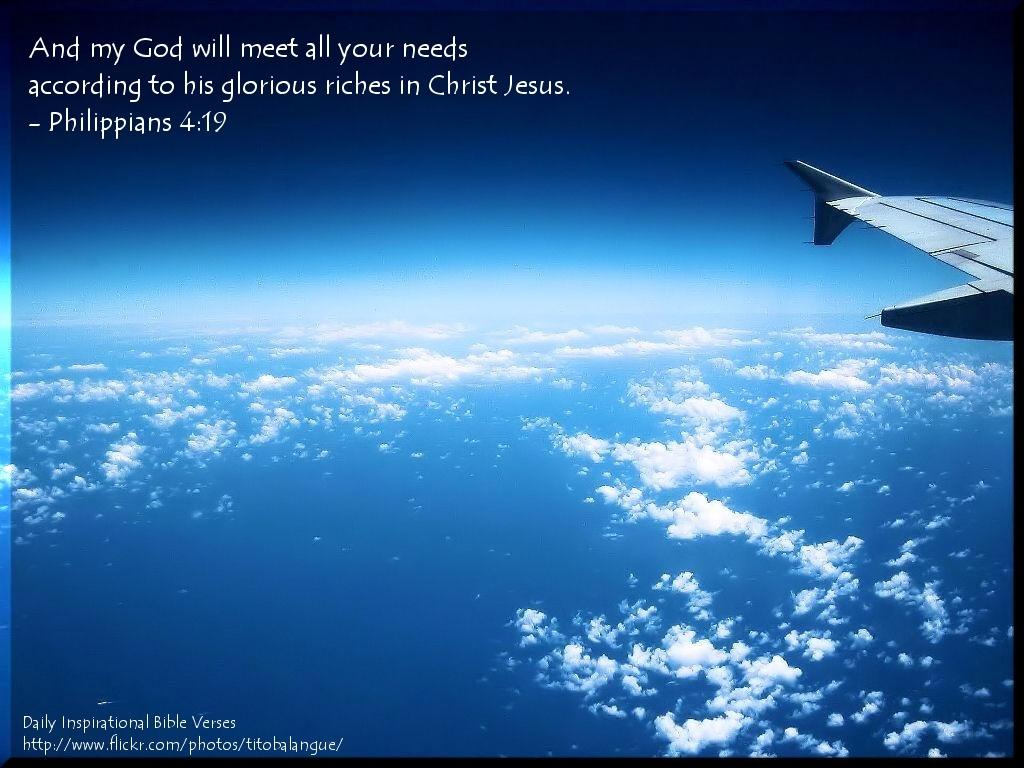<image>
Create a compact narrative representing the image presented. An inspirational poster of an airplane flying above clouds with a Bible verse from Philippians 4:19. 